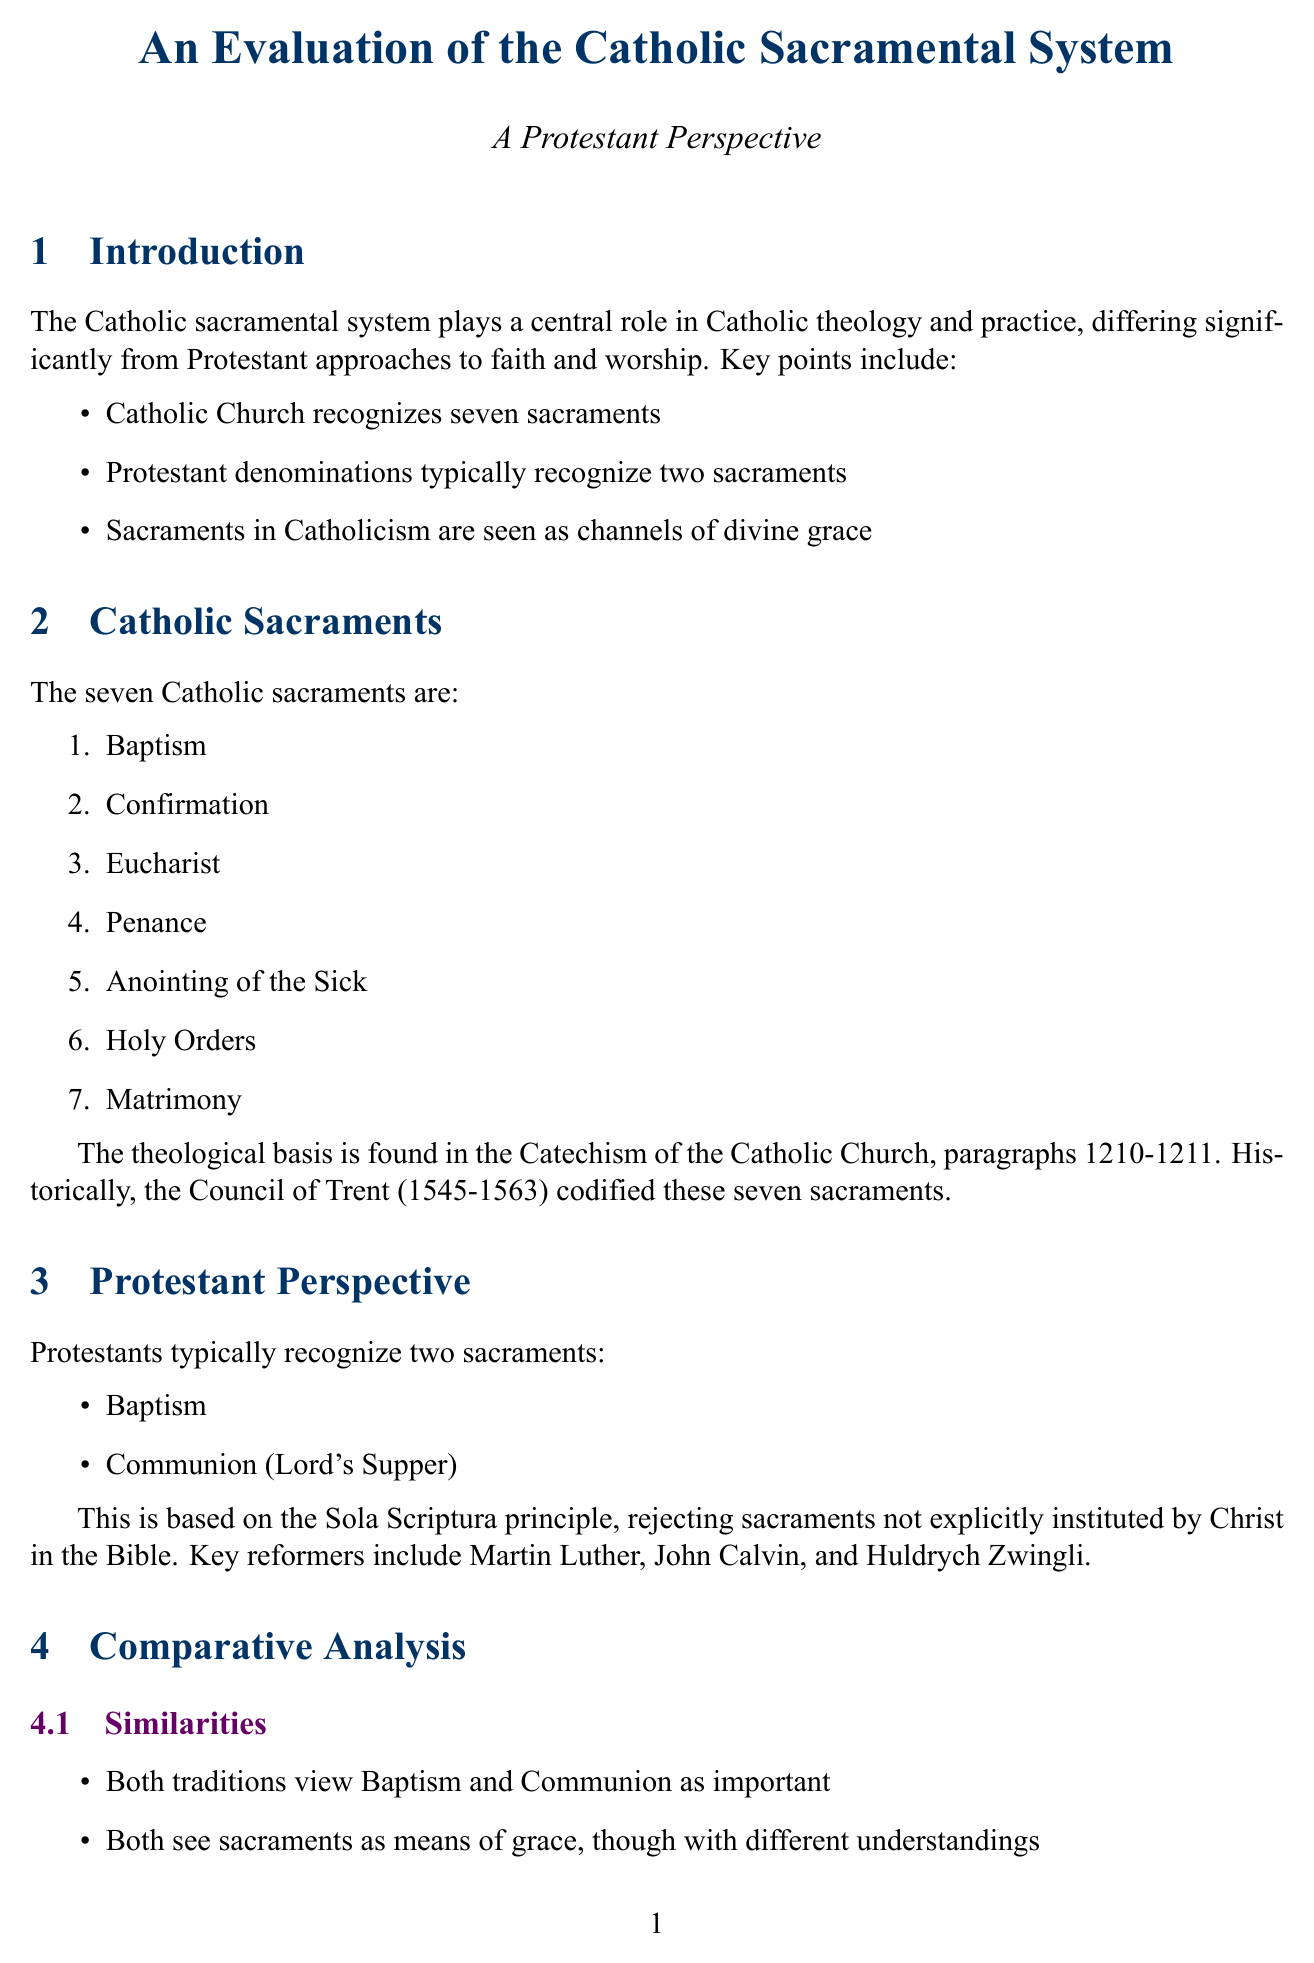What are the seven sacraments in Catholicism? The document lists the seven sacraments recognized by the Catholic Church.
Answer: Baptism, Confirmation, Eucharist, Penance, Anointing of the Sick, Holy Orders, Matrimony Which theological basis do Protestants rely on regarding sacraments? The document mentions a specific principle that Protestants follow, which guides their understanding of sacraments.
Answer: Sola Scriptura What is the Protestant perspective on the role of clergy in mediating grace? The document describes the Protestant view on clergy and its implications on faith practice.
Answer: Diminished role of clergy What historical event codified the seven sacraments in Catholicism? The document references an ecumenical council that solidified the understanding of sacraments in Catholic teaching.
Answer: Council of Trent What is a key difference in the understanding of sacraments between Catholics and Protestants? The document outlines differing views on how sacraments function within each tradition.
Answer: Efficacious ex opere operato How do both traditions view Baptism and Communion? The document notes a commonality in the perception of these two practices among the faiths.
Answer: Important Which significant document discusses Baptism, Eucharist and Ministry? The document lists a key ecumenical document relevant to discussions between the two traditions.
Answer: Baptism, Eucharist and Ministry How does the document describe the Catholic view of transubstantiation? The document highlights a distinct belief held within Catholic theology concerning the Eucharist.
Answer: Catholic belief in transubstantiation What reflection point questions the impact of sacramental views on Christian unity? The document poses several questions to consider regarding the consequences of sacramental theology.
Answer: How do differing views on sacraments affect Christian unity? 